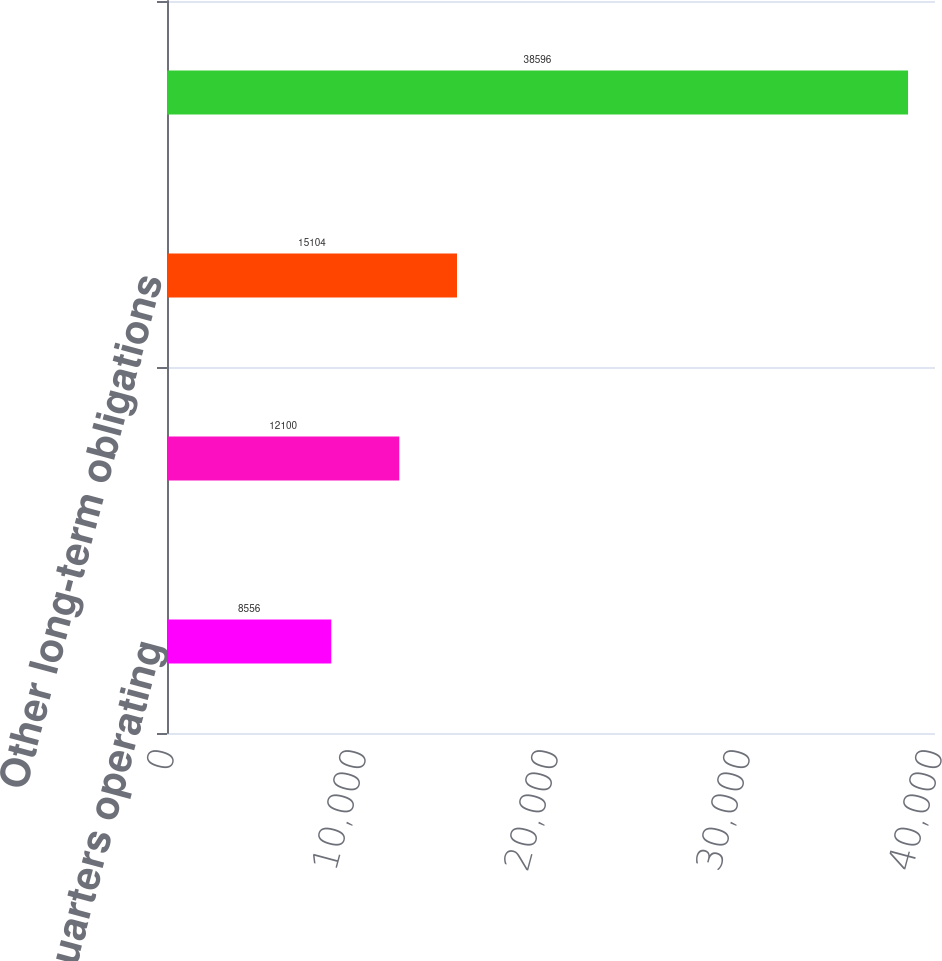Convert chart. <chart><loc_0><loc_0><loc_500><loc_500><bar_chart><fcel>Global headquarters operating<fcel>Other operating leases (2)<fcel>Other long-term obligations<fcel>Total contractual obligations<nl><fcel>8556<fcel>12100<fcel>15104<fcel>38596<nl></chart> 